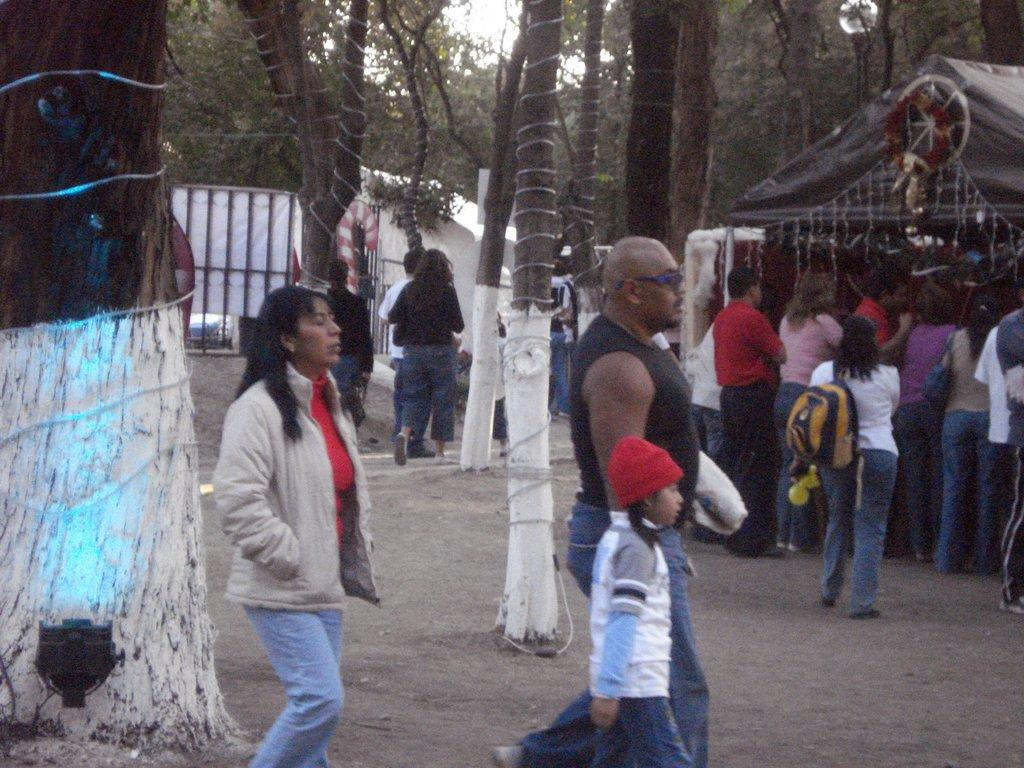Who or what can be seen in the image? There are people in the image. What type of structure is present in the image? There is a wall and a gate in the image. What type of vegetation is visible in the image? There are trees in the image. What is visible at the top of the image? The sky is visible at the top of the image. Is there an island visible in the image? No, there is no island present in the image. Can you see a plane flying in the sky in the image? No, there is no plane visible in the image. 